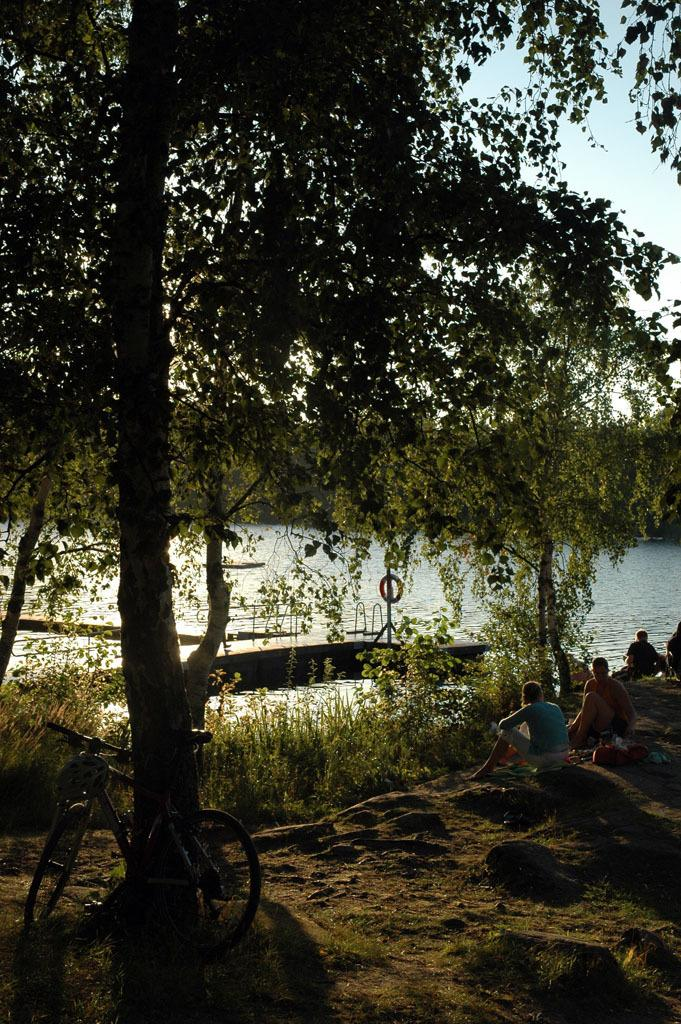What are the people in the image doing? The people in the image are sitting on rocks. What can be seen besides the people in the image? There is a bicycle, trees, plants, grass, a bridge, and the sky visible in the image. What type of vegetation is present in the image? There are trees and plants in the image. What is the terrain like in the image? The terrain includes rocks, grass, and a bridge. What type of locket is hanging from the bridge in the image? There is no locket hanging from the bridge in the image. How many doors can be seen on the bicycle in the image? There are no doors present on the bicycle in the image. 